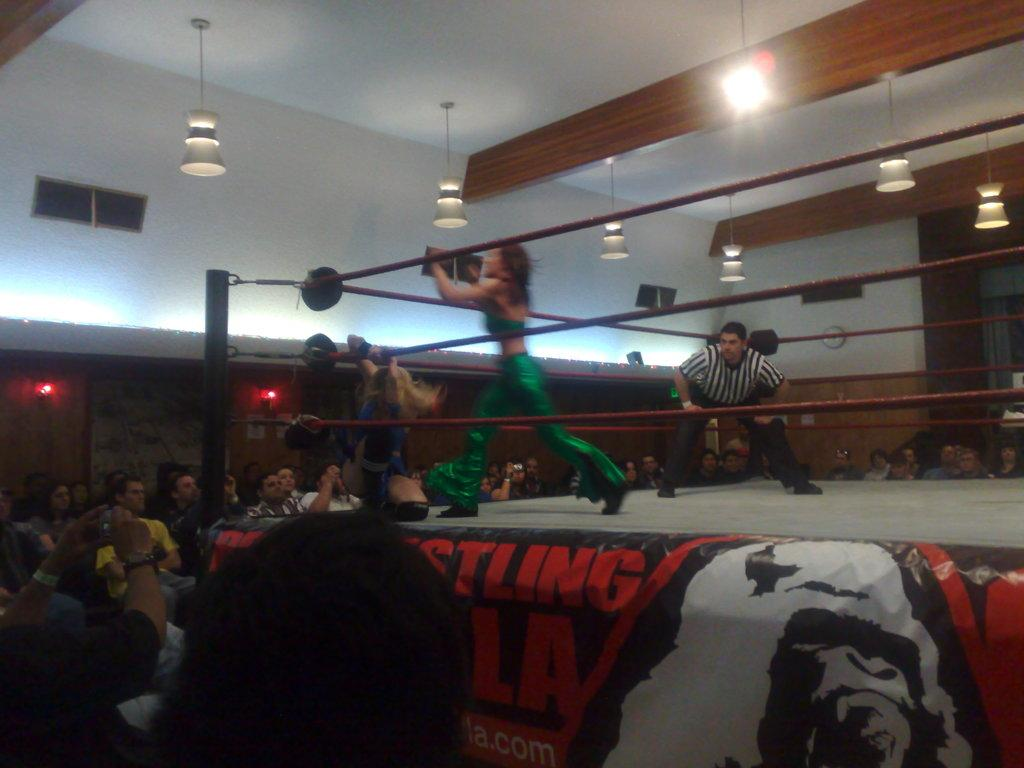What can be seen on the right side of the image? There are people on the right side of the image. What can be seen on the left side of the image? There are people on the left side of the image. What is the main feature in the center of the image? There is a wrestling ring in the center of the image. What objects are located at the top side of the image? There are lamps at the top side of the image. What flavor of ice cream does the owner of the wrestling ring prefer? There is no information about ice cream or an owner in the image, so this question cannot be answered. 